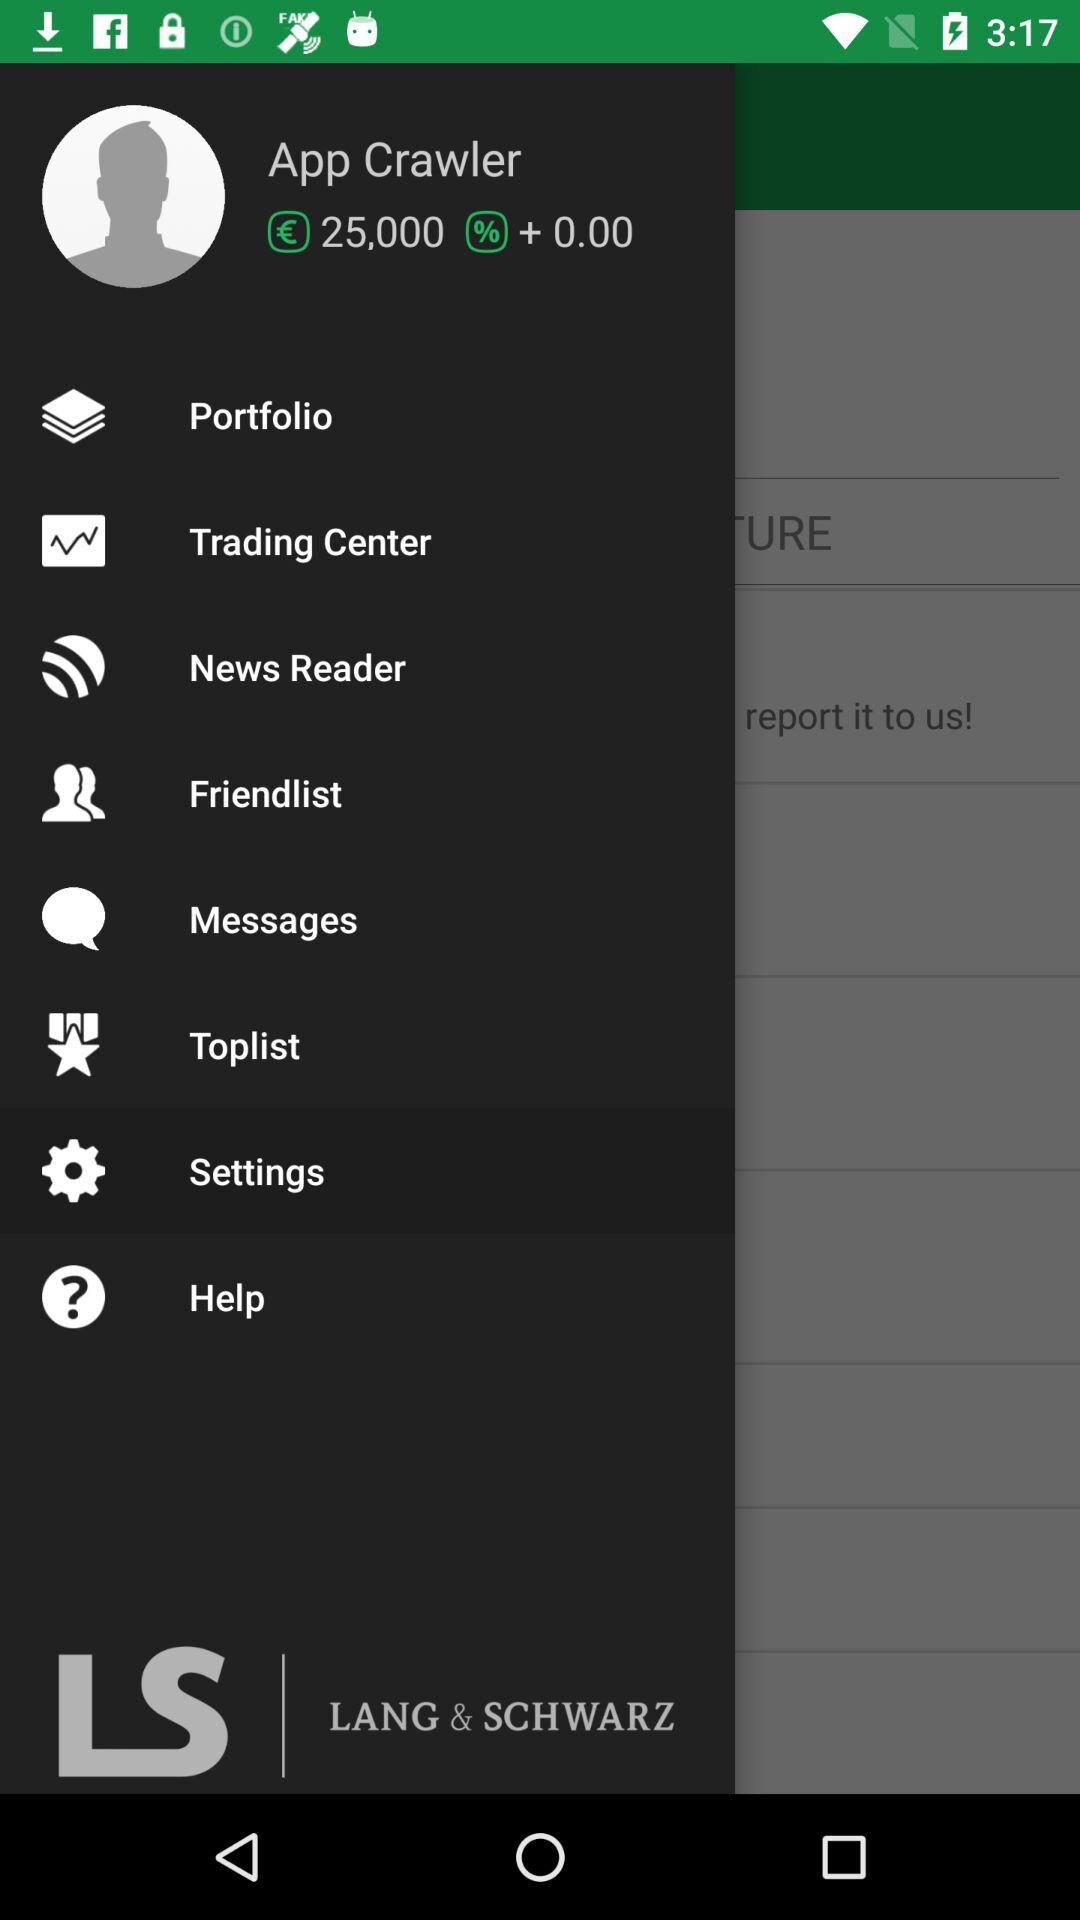What is the application name? The application name is "LANG & SCHWARZ TradeCenter". 